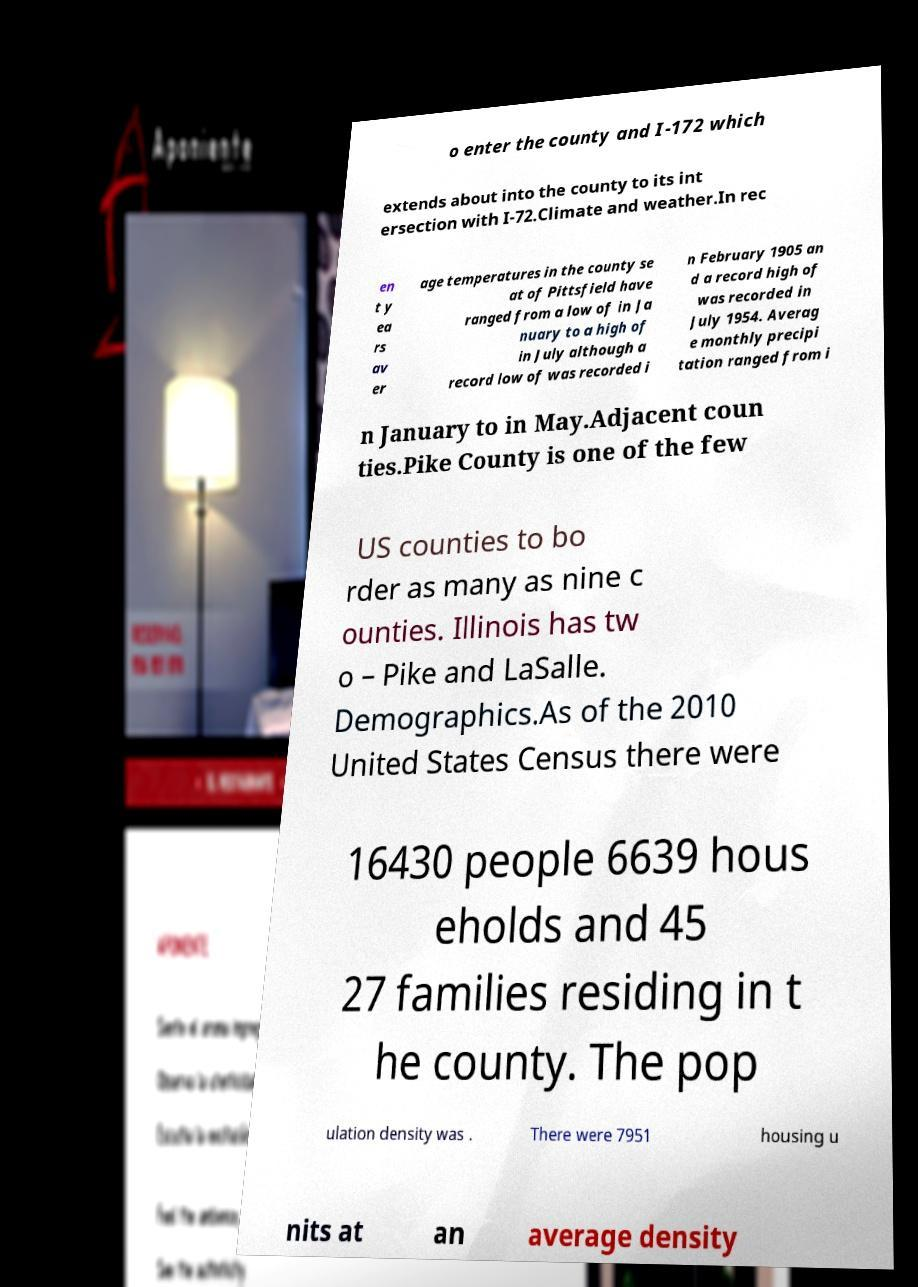For documentation purposes, I need the text within this image transcribed. Could you provide that? o enter the county and I-172 which extends about into the county to its int ersection with I-72.Climate and weather.In rec en t y ea rs av er age temperatures in the county se at of Pittsfield have ranged from a low of in Ja nuary to a high of in July although a record low of was recorded i n February 1905 an d a record high of was recorded in July 1954. Averag e monthly precipi tation ranged from i n January to in May.Adjacent coun ties.Pike County is one of the few US counties to bo rder as many as nine c ounties. Illinois has tw o – Pike and LaSalle. Demographics.As of the 2010 United States Census there were 16430 people 6639 hous eholds and 45 27 families residing in t he county. The pop ulation density was . There were 7951 housing u nits at an average density 